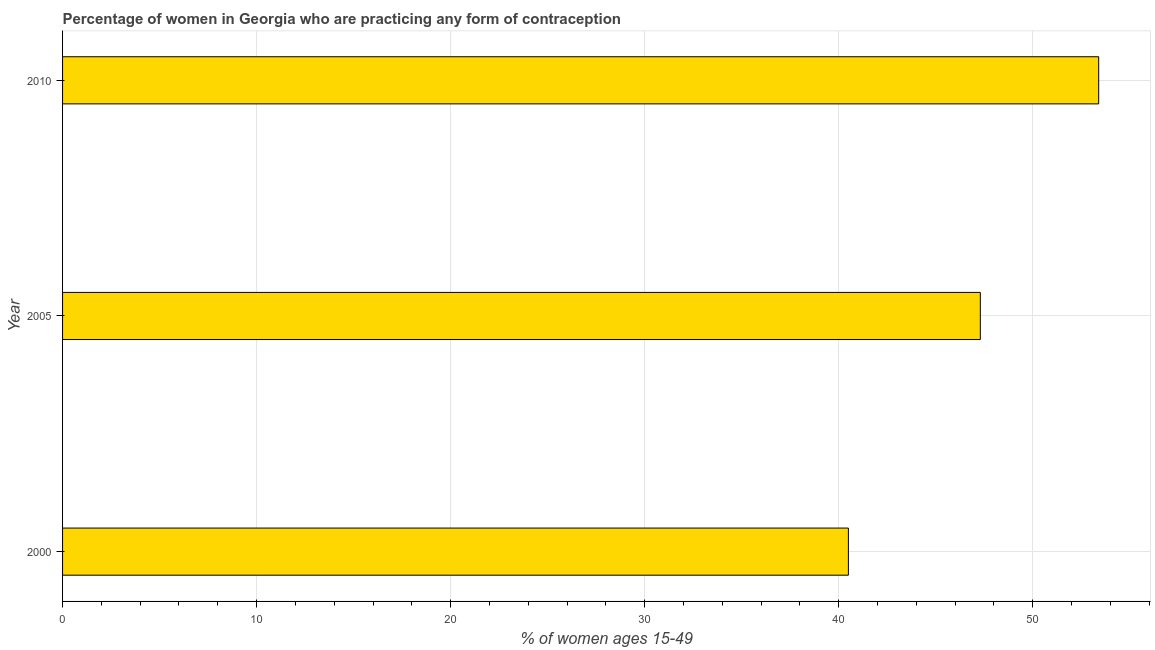Does the graph contain grids?
Provide a short and direct response. Yes. What is the title of the graph?
Your answer should be compact. Percentage of women in Georgia who are practicing any form of contraception. What is the label or title of the X-axis?
Your answer should be very brief. % of women ages 15-49. What is the contraceptive prevalence in 2005?
Ensure brevity in your answer.  47.3. Across all years, what is the maximum contraceptive prevalence?
Your answer should be very brief. 53.4. Across all years, what is the minimum contraceptive prevalence?
Offer a terse response. 40.5. What is the sum of the contraceptive prevalence?
Offer a very short reply. 141.2. What is the difference between the contraceptive prevalence in 2000 and 2005?
Ensure brevity in your answer.  -6.8. What is the average contraceptive prevalence per year?
Your answer should be very brief. 47.07. What is the median contraceptive prevalence?
Your answer should be compact. 47.3. What is the ratio of the contraceptive prevalence in 2000 to that in 2010?
Make the answer very short. 0.76. Is the contraceptive prevalence in 2005 less than that in 2010?
Your answer should be very brief. Yes. Is the difference between the contraceptive prevalence in 2000 and 2010 greater than the difference between any two years?
Keep it short and to the point. Yes. Is the sum of the contraceptive prevalence in 2000 and 2010 greater than the maximum contraceptive prevalence across all years?
Ensure brevity in your answer.  Yes. What is the difference between the highest and the lowest contraceptive prevalence?
Provide a succinct answer. 12.9. In how many years, is the contraceptive prevalence greater than the average contraceptive prevalence taken over all years?
Offer a terse response. 2. Are all the bars in the graph horizontal?
Provide a short and direct response. Yes. What is the difference between two consecutive major ticks on the X-axis?
Keep it short and to the point. 10. Are the values on the major ticks of X-axis written in scientific E-notation?
Your answer should be compact. No. What is the % of women ages 15-49 of 2000?
Your answer should be very brief. 40.5. What is the % of women ages 15-49 in 2005?
Provide a short and direct response. 47.3. What is the % of women ages 15-49 in 2010?
Provide a short and direct response. 53.4. What is the ratio of the % of women ages 15-49 in 2000 to that in 2005?
Your answer should be very brief. 0.86. What is the ratio of the % of women ages 15-49 in 2000 to that in 2010?
Make the answer very short. 0.76. What is the ratio of the % of women ages 15-49 in 2005 to that in 2010?
Your answer should be very brief. 0.89. 